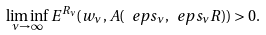<formula> <loc_0><loc_0><loc_500><loc_500>\liminf _ { \nu \to \infty } E ^ { R _ { \nu } } ( w _ { \nu } , A ( \ e p s _ { \nu } , \ e p s _ { \nu } R ) ) > 0 .</formula> 